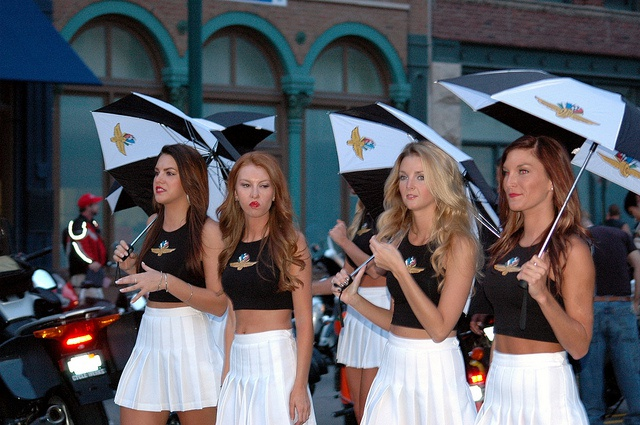Describe the objects in this image and their specific colors. I can see people in navy, lavender, gray, black, and tan tones, people in navy, white, brown, black, and maroon tones, people in navy, lavender, black, brown, and maroon tones, people in navy, lavender, brown, black, and maroon tones, and umbrella in navy, lightblue, black, and darkgray tones in this image. 